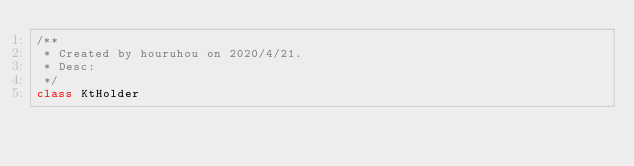<code> <loc_0><loc_0><loc_500><loc_500><_Kotlin_>/**
 * Created by houruhou on 2020/4/21.
 * Desc:
 */
class KtHolder</code> 